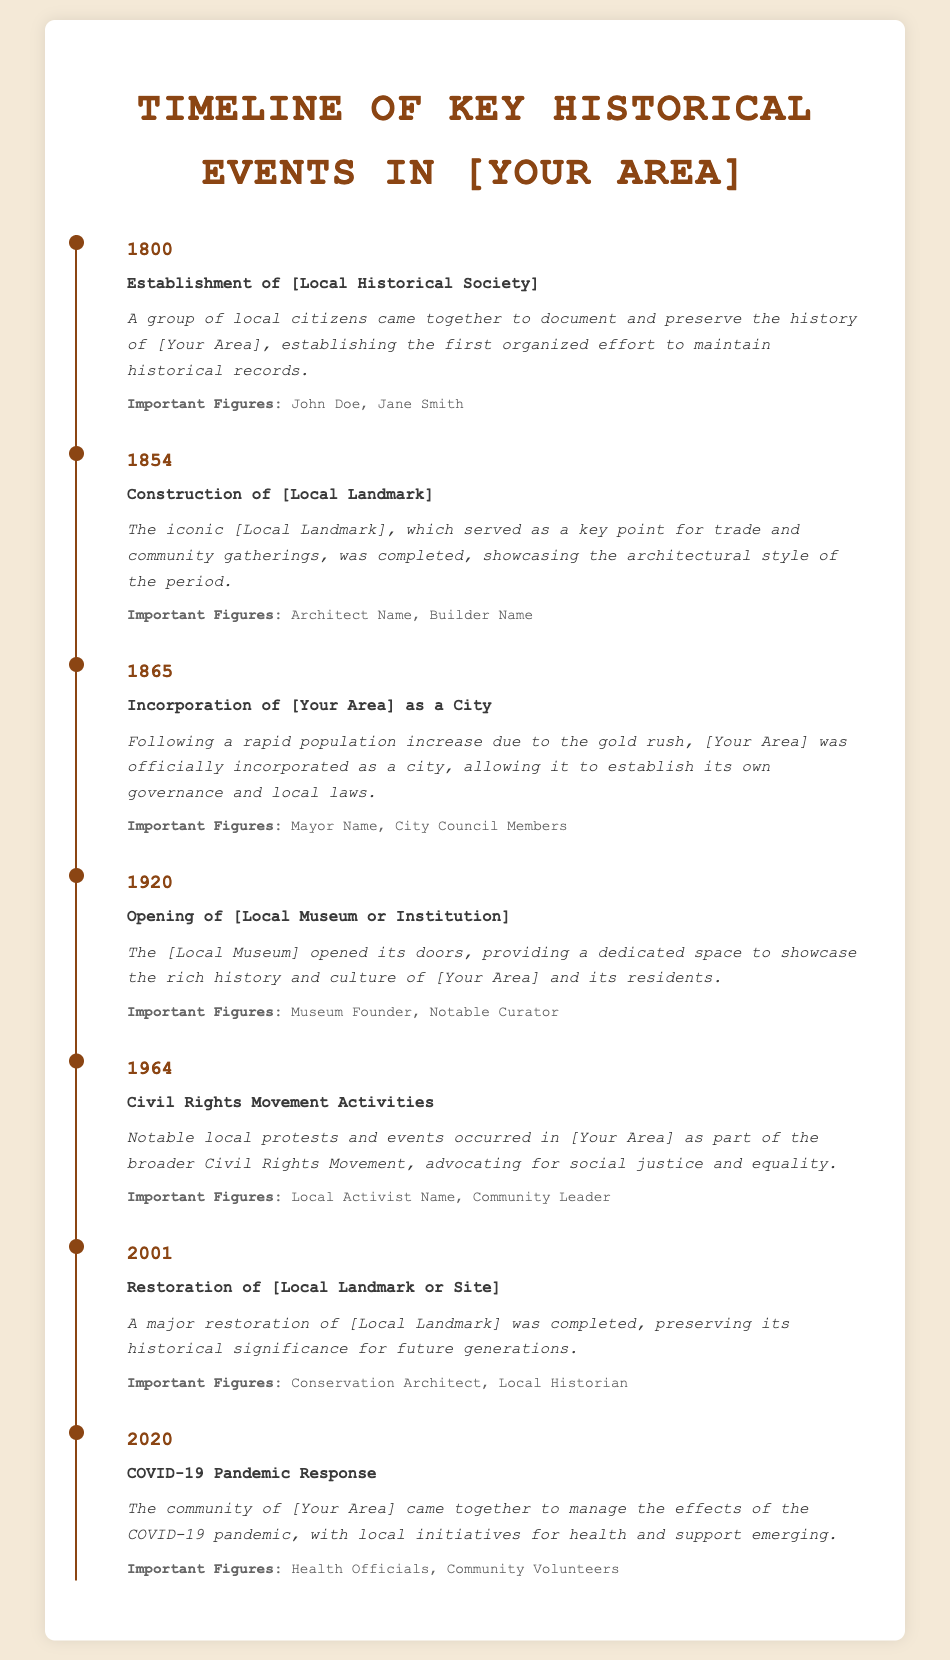What year was the [Local Historical Society] established? The establishment of the [Local Historical Society] occurred in the year 1800.
Answer: 1800 Who are the important figures associated with the 1854 event? The important figures associated with the construction of [Local Landmark] in 1854 are Architect Name and Builder Name.
Answer: Architect Name, Builder Name What significant event occurred in 1964 in [Your Area]? In 1964, notable local protests and events occurred as part of the broader Civil Rights Movement.
Answer: Civil Rights Movement Activities What was the outcome of the incorporation of [Your Area] in 1865? The incorporation allowed [Your Area] to establish its own governance and local laws.
Answer: Established governance Which local institution opened in 1920? The [Local Museum] opened its doors in 1920, dedicated to showcasing the area's rich history.
Answer: [Local Museum] What event does the year 2001 signify for [Local Landmark]? The year 2001 signifies the restoration of [Local Landmark], preserving its historical significance.
Answer: Restoration What community response took place in 2020 in [Your Area]? The community came together to manage the effects of the COVID-19 pandemic in 2020.
Answer: COVID-19 Pandemic Response What is the architectural significance of the 1854 construction? The construction of [Local Landmark] showcased the architectural style of the period.
Answer: Architectural style 